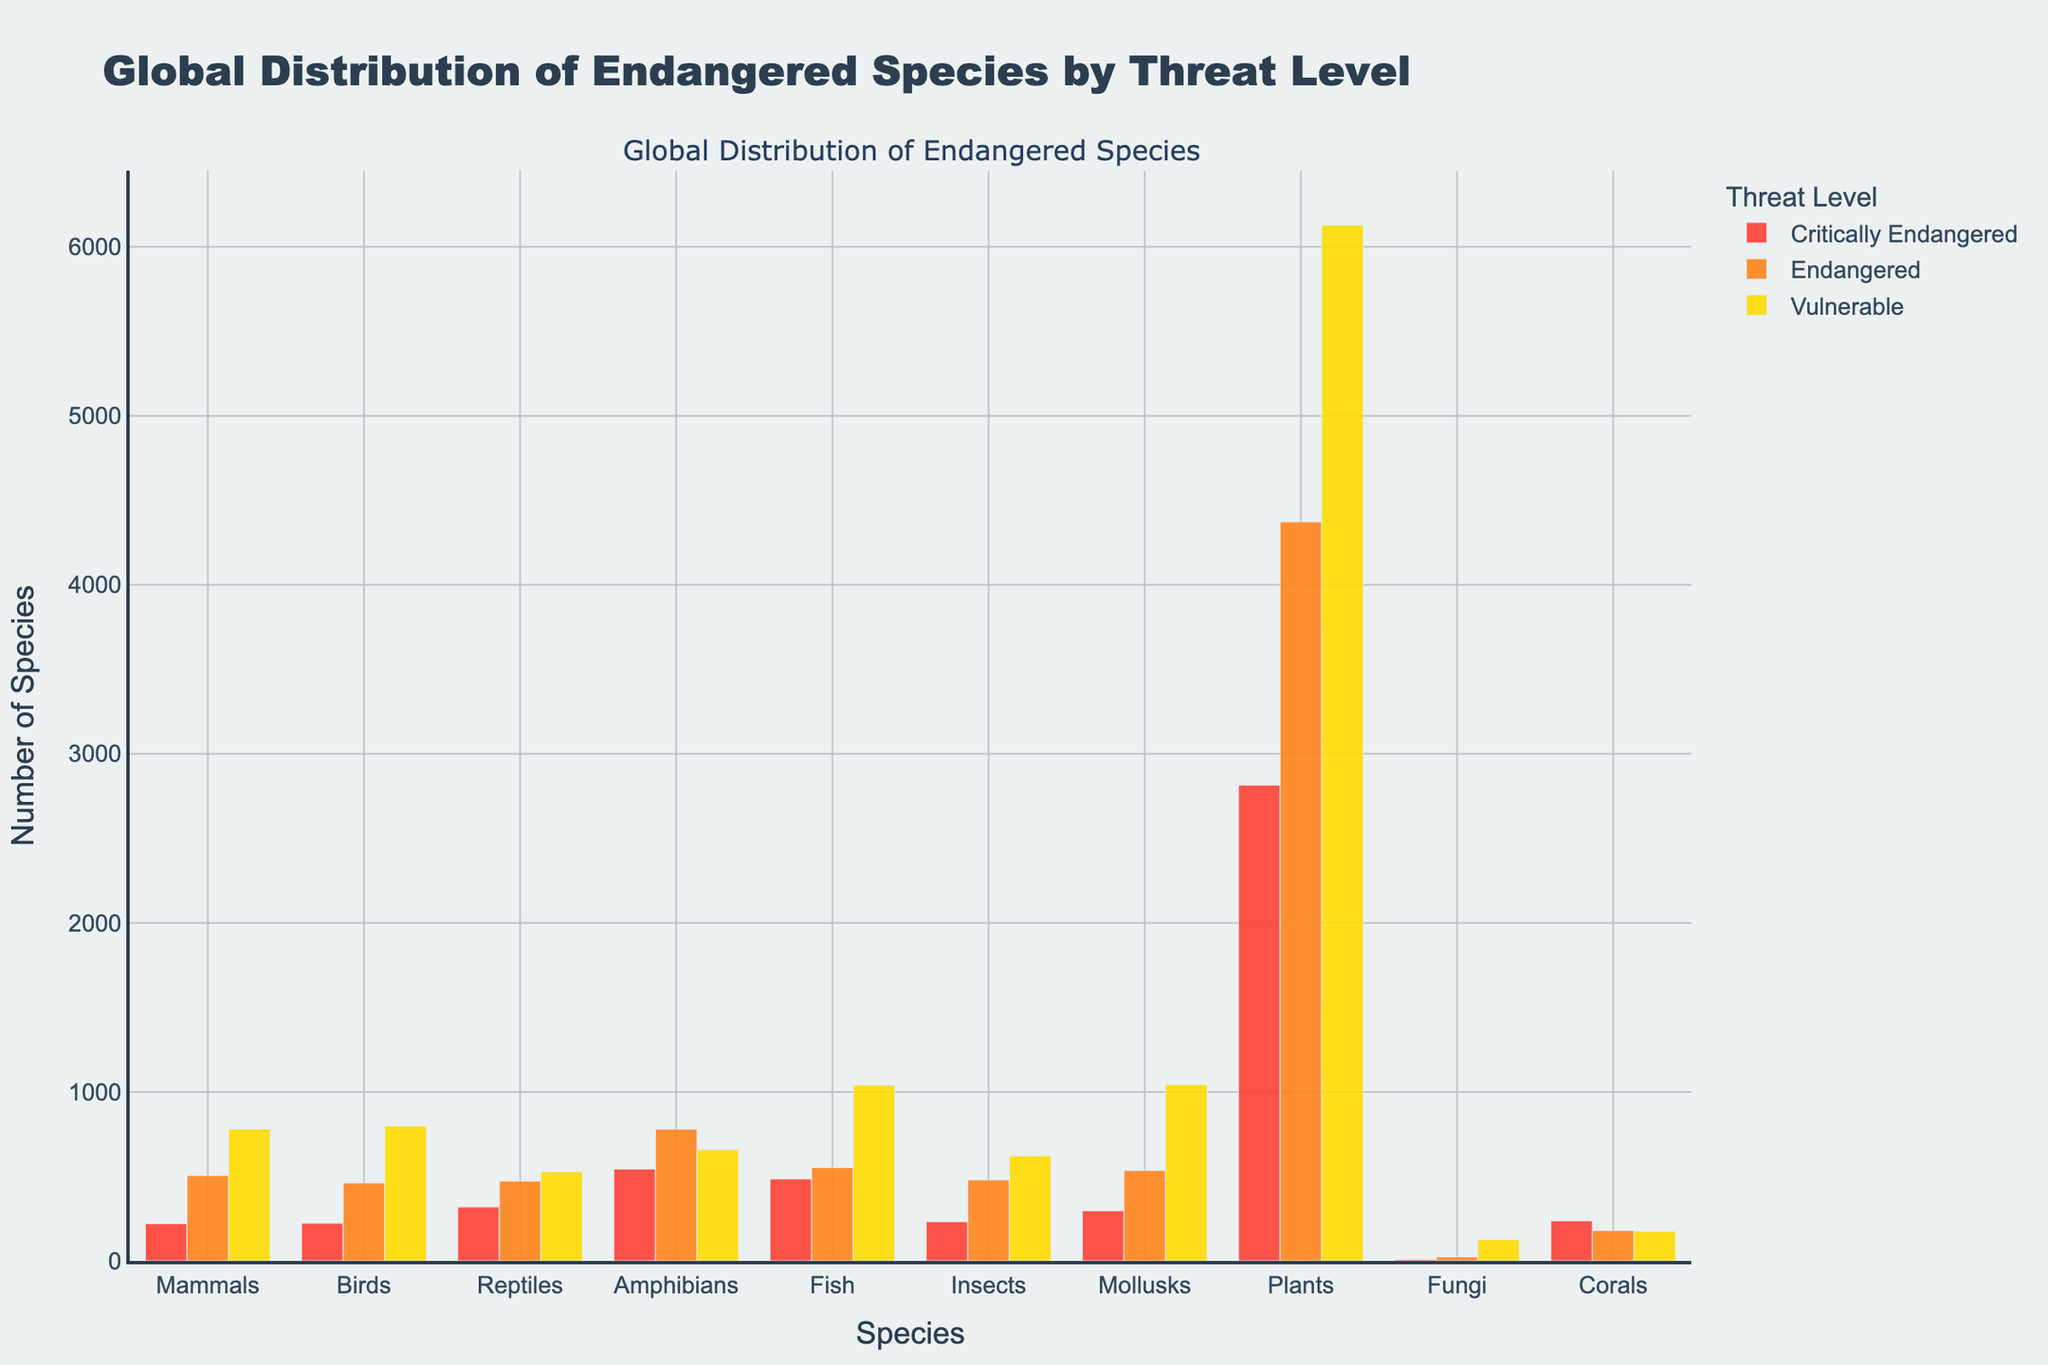what is the total number of Critically Endangered, Endangered, and Vulnerable species among Amphibians? First, find the number of Critically Endangered, Endangered, and Vulnerable species in Amphibians: 544, 779, and 657, respectively. Then sum them up: 544 + 779 + 657 = 1980
Answer: 1980 Which species has the highest number of Endangered individuals? Look at the Endangered category and compare the heights of the bars. The Plants bar is the tallest. The number of Endangered species in Plants is 4372, which is the highest.
Answer: Plants What is the difference between the number of Critically Endangered and Vulnerable Birds? Find the number of Critically Endangered Birds (223) and Vulnerable Birds (798). Then calculate the difference: 798 - 223 = 575
Answer: 575 Which has more Critically Endangered species: Mammals or Reptiles? Compare the bars for Mammals (221) and Reptiles (319) in the Critically Endangered category. Reptiles have a higher count (319).
Answer: Reptiles What is the proportion of Vulnerable Fungi compared to Total Vulnerable species? First, sum all Vulnerable species: 780 + 798 + 527 + 657 + 1040 + 621 + 1044 + 6128 + 126 + 176 = 11897. Then find the Vulnerable Fungi: 126. Calculate the proportion: 126 / 11897 ≈ 0.0106
Answer: 0.0106 Which threat level category (Critically Endangered, Endangered, or Vulnerable) has the most individuals overall across all species? Sum up the counts for each threat level:
Critically Endangered: 221 + 223 + 319 + 544 + 485 + 232 + 297 + 2815 + 9 + 237 = 5382
Endangered: 505 + 461 + 473 + 779 + 552 + 479 + 535 + 4372 + 24 + 180 = 9360
Vulnerable: 780 + 798 + 527 + 657 + 1040 + 621 + 1044 + 6128 + 126 + 176 = 11897
Vulnerable has the highest overall count (11897).
Answer: Vulnerable Which species has the smallest number of Critically Endangered individuals? Look at the Critically Endangered category and find the smallest bar. Fungi have the smallest bar (9).
Answer: Fungi For Insects, how does the number of Critically Endangered species compare to the number of Vulnerable species? Look at the bars for Insects. Critically Endangered species count is 232, and Vulnerable species count is 621. Compare the two counts: 232 < 621.
Answer: Critically Endangered < Vulnerable Do Birds have more Endangered or Vulnerable species? Compare the Endangered Birds (461) with Vulnerable Birds (798). 798 is greater than 461, so there are more Vulnerable Birds.
Answer: Vulnerable What is the average number of Critically Endangered species across all listed species? Sum up the counts of Critically Endangered species and divide by the number of species: (221 + 223 + 319 + 544 + 485 + 232 + 297 + 2815 + 9 + 237) / 10 = 5382 / 10 = 538.2
Answer: 538.2 